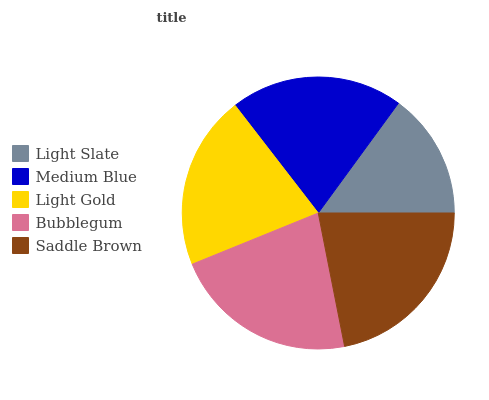Is Light Slate the minimum?
Answer yes or no. Yes. Is Bubblegum the maximum?
Answer yes or no. Yes. Is Medium Blue the minimum?
Answer yes or no. No. Is Medium Blue the maximum?
Answer yes or no. No. Is Medium Blue greater than Light Slate?
Answer yes or no. Yes. Is Light Slate less than Medium Blue?
Answer yes or no. Yes. Is Light Slate greater than Medium Blue?
Answer yes or no. No. Is Medium Blue less than Light Slate?
Answer yes or no. No. Is Light Gold the high median?
Answer yes or no. Yes. Is Light Gold the low median?
Answer yes or no. Yes. Is Medium Blue the high median?
Answer yes or no. No. Is Saddle Brown the low median?
Answer yes or no. No. 